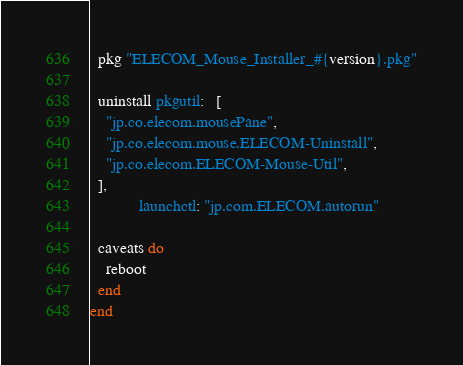<code> <loc_0><loc_0><loc_500><loc_500><_Ruby_>  pkg "ELECOM_Mouse_Installer_#{version}.pkg"

  uninstall pkgutil:   [
    "jp.co.elecom.mousePane",
    "jp.co.elecom.mouse.ELECOM-Uninstall",
    "jp.co.elecom.ELECOM-Mouse-Util",
  ],
            launchctl: "jp.com.ELECOM.autorun"

  caveats do
    reboot
  end
end
</code> 